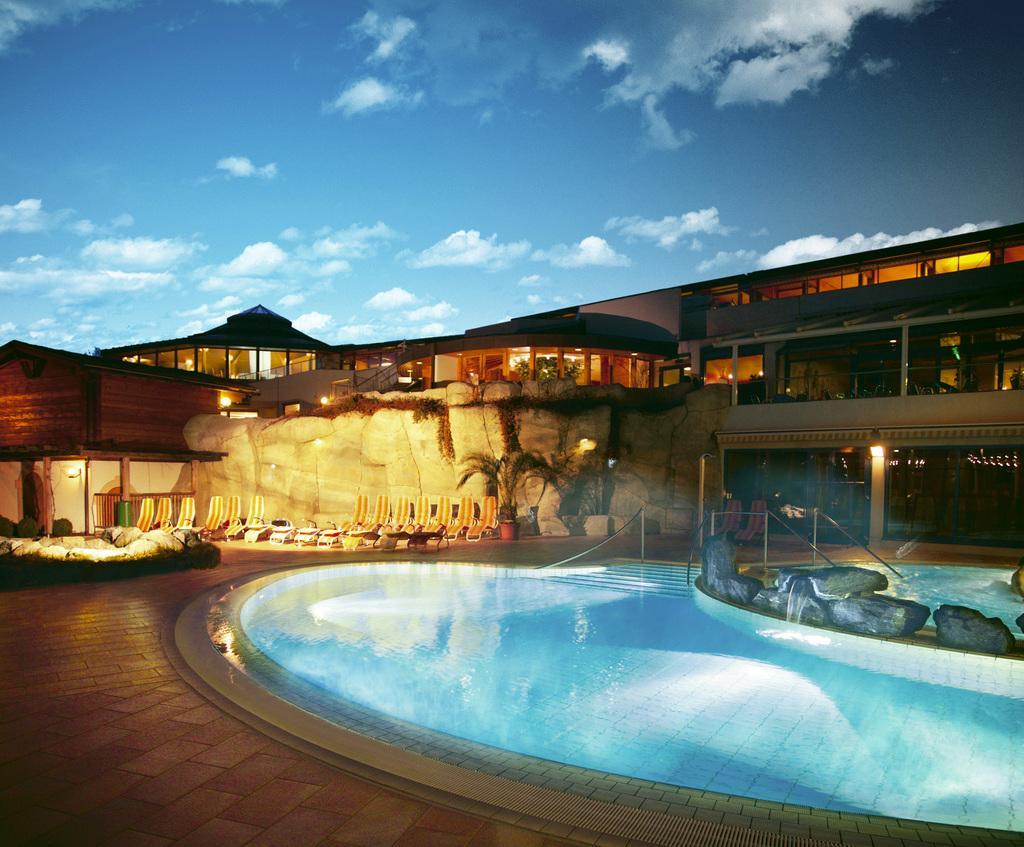Please provide a concise description of this image. In this image in front there is a swimming pool. There are rocks. At the bottom of the image there is a floor. On the left side of the image there are chairs. There are plants. In the background of the image there are buildings, lights and sky. 